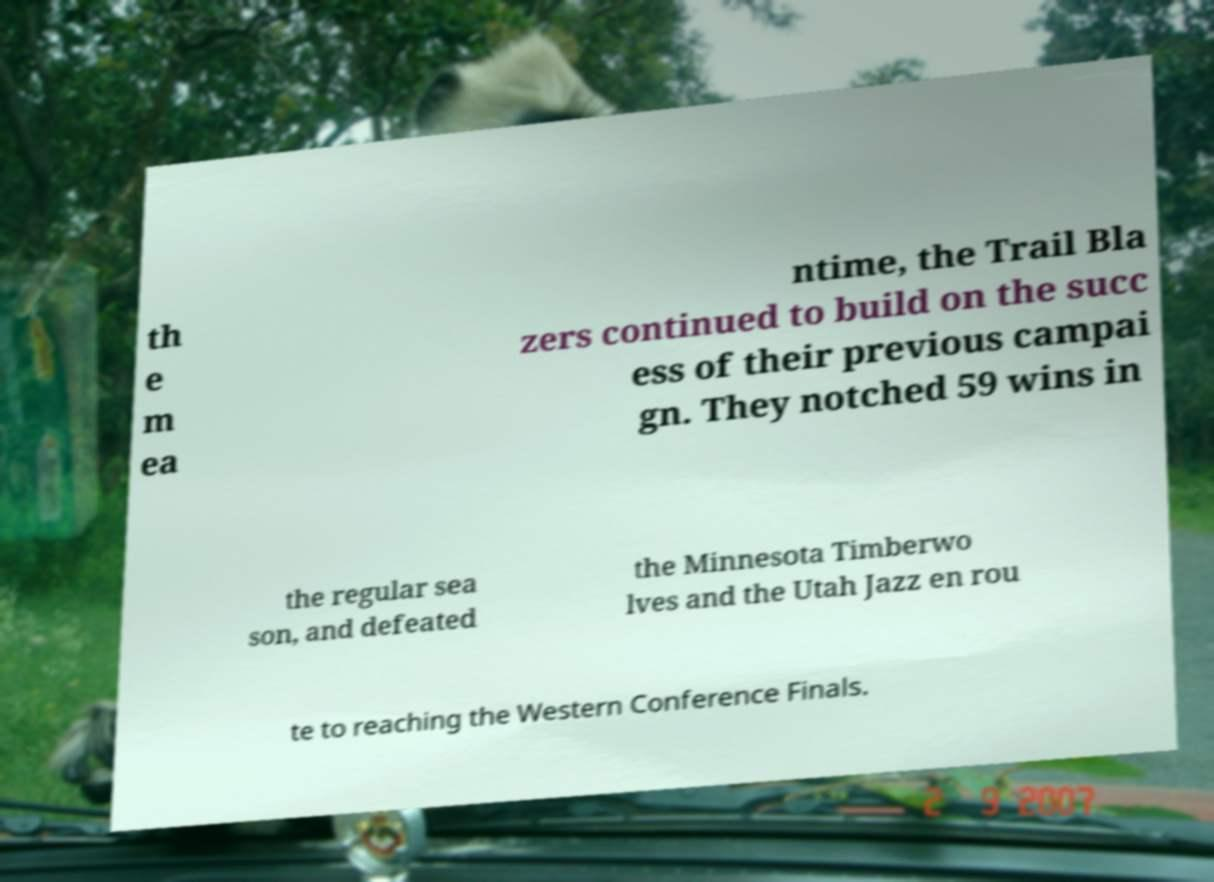For documentation purposes, I need the text within this image transcribed. Could you provide that? th e m ea ntime, the Trail Bla zers continued to build on the succ ess of their previous campai gn. They notched 59 wins in the regular sea son, and defeated the Minnesota Timberwo lves and the Utah Jazz en rou te to reaching the Western Conference Finals. 